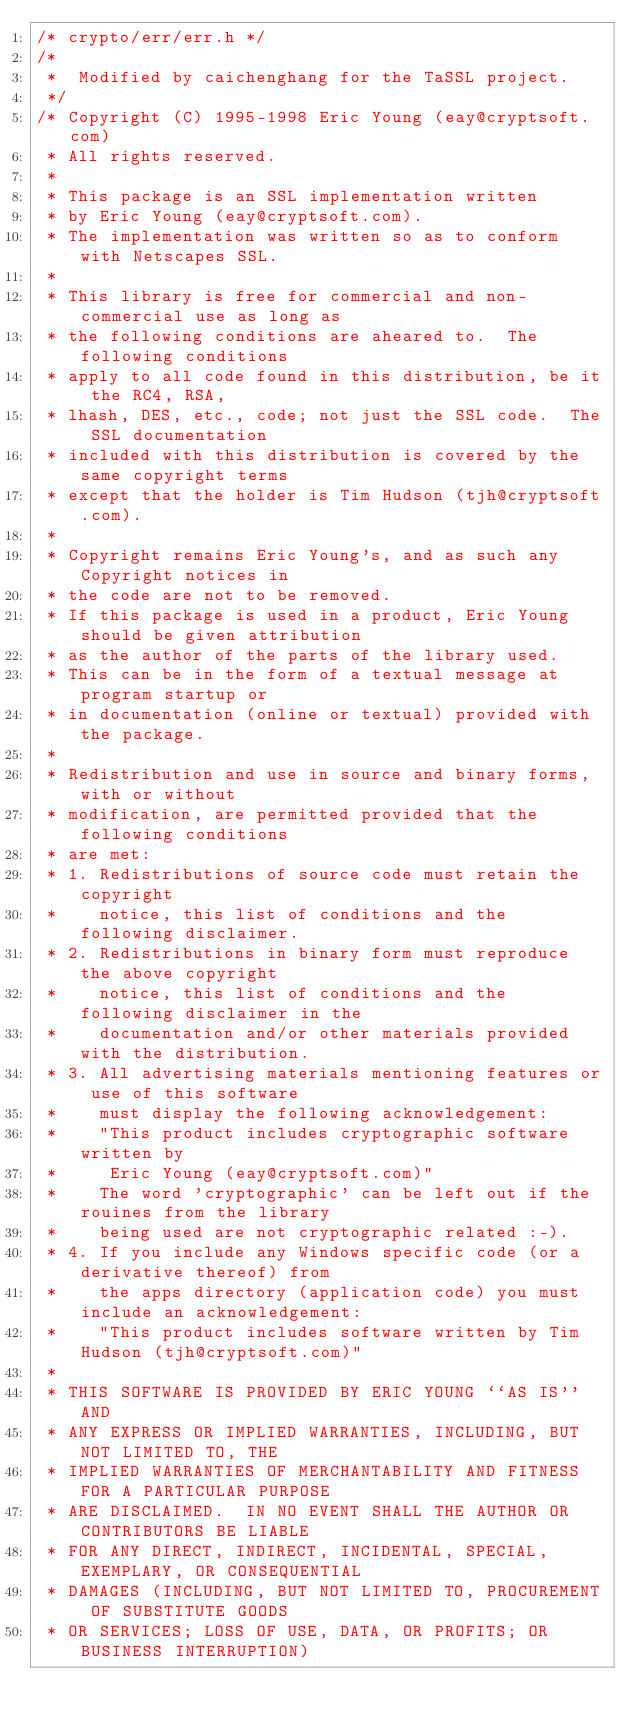<code> <loc_0><loc_0><loc_500><loc_500><_C_>/* crypto/err/err.h */
/*
 *  Modified by caichenghang for the TaSSL project.
 */
/* Copyright (C) 1995-1998 Eric Young (eay@cryptsoft.com)
 * All rights reserved.
 *
 * This package is an SSL implementation written
 * by Eric Young (eay@cryptsoft.com).
 * The implementation was written so as to conform with Netscapes SSL.
 *
 * This library is free for commercial and non-commercial use as long as
 * the following conditions are aheared to.  The following conditions
 * apply to all code found in this distribution, be it the RC4, RSA,
 * lhash, DES, etc., code; not just the SSL code.  The SSL documentation
 * included with this distribution is covered by the same copyright terms
 * except that the holder is Tim Hudson (tjh@cryptsoft.com).
 *
 * Copyright remains Eric Young's, and as such any Copyright notices in
 * the code are not to be removed.
 * If this package is used in a product, Eric Young should be given attribution
 * as the author of the parts of the library used.
 * This can be in the form of a textual message at program startup or
 * in documentation (online or textual) provided with the package.
 *
 * Redistribution and use in source and binary forms, with or without
 * modification, are permitted provided that the following conditions
 * are met:
 * 1. Redistributions of source code must retain the copyright
 *    notice, this list of conditions and the following disclaimer.
 * 2. Redistributions in binary form must reproduce the above copyright
 *    notice, this list of conditions and the following disclaimer in the
 *    documentation and/or other materials provided with the distribution.
 * 3. All advertising materials mentioning features or use of this software
 *    must display the following acknowledgement:
 *    "This product includes cryptographic software written by
 *     Eric Young (eay@cryptsoft.com)"
 *    The word 'cryptographic' can be left out if the rouines from the library
 *    being used are not cryptographic related :-).
 * 4. If you include any Windows specific code (or a derivative thereof) from
 *    the apps directory (application code) you must include an acknowledgement:
 *    "This product includes software written by Tim Hudson (tjh@cryptsoft.com)"
 *
 * THIS SOFTWARE IS PROVIDED BY ERIC YOUNG ``AS IS'' AND
 * ANY EXPRESS OR IMPLIED WARRANTIES, INCLUDING, BUT NOT LIMITED TO, THE
 * IMPLIED WARRANTIES OF MERCHANTABILITY AND FITNESS FOR A PARTICULAR PURPOSE
 * ARE DISCLAIMED.  IN NO EVENT SHALL THE AUTHOR OR CONTRIBUTORS BE LIABLE
 * FOR ANY DIRECT, INDIRECT, INCIDENTAL, SPECIAL, EXEMPLARY, OR CONSEQUENTIAL
 * DAMAGES (INCLUDING, BUT NOT LIMITED TO, PROCUREMENT OF SUBSTITUTE GOODS
 * OR SERVICES; LOSS OF USE, DATA, OR PROFITS; OR BUSINESS INTERRUPTION)</code> 